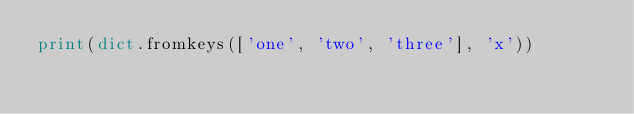Convert code to text. <code><loc_0><loc_0><loc_500><loc_500><_Python_>print(dict.fromkeys(['one', 'two', 'three'], 'x'))
</code> 